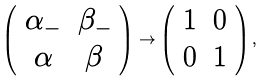<formula> <loc_0><loc_0><loc_500><loc_500>\left ( \begin{array} { c c } \alpha _ { - } & \beta _ { - } \\ \alpha & \beta \end{array} \right ) \rightarrow \left ( \begin{array} { c c } 1 & 0 \\ 0 & 1 \end{array} \right ) ,</formula> 